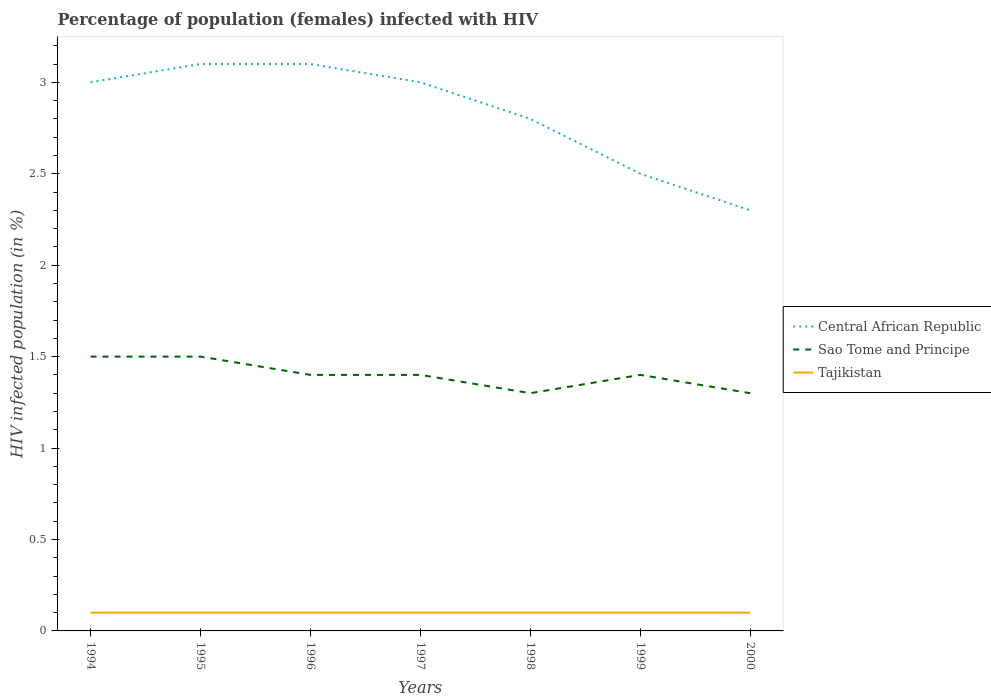How many different coloured lines are there?
Make the answer very short. 3. What is the total percentage of HIV infected female population in Tajikistan in the graph?
Your answer should be compact. 0. What is the difference between the highest and the second highest percentage of HIV infected female population in Tajikistan?
Offer a very short reply. 0. What is the difference between the highest and the lowest percentage of HIV infected female population in Tajikistan?
Provide a short and direct response. 7. Is the percentage of HIV infected female population in Sao Tome and Principe strictly greater than the percentage of HIV infected female population in Central African Republic over the years?
Keep it short and to the point. Yes. What is the difference between two consecutive major ticks on the Y-axis?
Make the answer very short. 0.5. Does the graph contain any zero values?
Offer a terse response. No. How are the legend labels stacked?
Make the answer very short. Vertical. What is the title of the graph?
Give a very brief answer. Percentage of population (females) infected with HIV. What is the label or title of the X-axis?
Your answer should be compact. Years. What is the label or title of the Y-axis?
Your answer should be compact. HIV infected population (in %). What is the HIV infected population (in %) of Central African Republic in 1994?
Offer a very short reply. 3. What is the HIV infected population (in %) of Tajikistan in 1994?
Offer a terse response. 0.1. What is the HIV infected population (in %) in Sao Tome and Principe in 1995?
Your answer should be very brief. 1.5. What is the HIV infected population (in %) of Tajikistan in 1995?
Ensure brevity in your answer.  0.1. What is the HIV infected population (in %) of Tajikistan in 1996?
Your answer should be very brief. 0.1. What is the HIV infected population (in %) of Central African Republic in 1997?
Your answer should be compact. 3. What is the HIV infected population (in %) of Central African Republic in 1999?
Make the answer very short. 2.5. What is the HIV infected population (in %) of Sao Tome and Principe in 1999?
Provide a short and direct response. 1.4. What is the HIV infected population (in %) in Tajikistan in 1999?
Make the answer very short. 0.1. What is the HIV infected population (in %) in Sao Tome and Principe in 2000?
Your answer should be compact. 1.3. What is the HIV infected population (in %) of Tajikistan in 2000?
Offer a very short reply. 0.1. Across all years, what is the maximum HIV infected population (in %) in Sao Tome and Principe?
Offer a very short reply. 1.5. Across all years, what is the maximum HIV infected population (in %) in Tajikistan?
Provide a succinct answer. 0.1. What is the total HIV infected population (in %) in Central African Republic in the graph?
Your response must be concise. 19.8. What is the total HIV infected population (in %) of Sao Tome and Principe in the graph?
Your response must be concise. 9.8. What is the total HIV infected population (in %) of Tajikistan in the graph?
Your answer should be very brief. 0.7. What is the difference between the HIV infected population (in %) in Sao Tome and Principe in 1994 and that in 1995?
Provide a short and direct response. 0. What is the difference between the HIV infected population (in %) of Central African Republic in 1994 and that in 1996?
Offer a terse response. -0.1. What is the difference between the HIV infected population (in %) in Sao Tome and Principe in 1994 and that in 1996?
Keep it short and to the point. 0.1. What is the difference between the HIV infected population (in %) of Tajikistan in 1994 and that in 1996?
Keep it short and to the point. 0. What is the difference between the HIV infected population (in %) of Sao Tome and Principe in 1994 and that in 1999?
Keep it short and to the point. 0.1. What is the difference between the HIV infected population (in %) in Tajikistan in 1994 and that in 2000?
Your answer should be very brief. 0. What is the difference between the HIV infected population (in %) in Tajikistan in 1995 and that in 1996?
Keep it short and to the point. 0. What is the difference between the HIV infected population (in %) in Central African Republic in 1995 and that in 1998?
Provide a succinct answer. 0.3. What is the difference between the HIV infected population (in %) of Sao Tome and Principe in 1995 and that in 1998?
Your response must be concise. 0.2. What is the difference between the HIV infected population (in %) of Tajikistan in 1995 and that in 1998?
Ensure brevity in your answer.  0. What is the difference between the HIV infected population (in %) of Central African Republic in 1995 and that in 2000?
Your answer should be very brief. 0.8. What is the difference between the HIV infected population (in %) in Sao Tome and Principe in 1996 and that in 1997?
Provide a short and direct response. 0. What is the difference between the HIV infected population (in %) of Sao Tome and Principe in 1996 and that in 1999?
Keep it short and to the point. 0. What is the difference between the HIV infected population (in %) of Tajikistan in 1996 and that in 1999?
Your answer should be very brief. 0. What is the difference between the HIV infected population (in %) of Tajikistan in 1996 and that in 2000?
Ensure brevity in your answer.  0. What is the difference between the HIV infected population (in %) in Central African Republic in 1997 and that in 1998?
Provide a short and direct response. 0.2. What is the difference between the HIV infected population (in %) in Tajikistan in 1997 and that in 1999?
Provide a short and direct response. 0. What is the difference between the HIV infected population (in %) of Central African Republic in 1997 and that in 2000?
Ensure brevity in your answer.  0.7. What is the difference between the HIV infected population (in %) in Sao Tome and Principe in 1997 and that in 2000?
Ensure brevity in your answer.  0.1. What is the difference between the HIV infected population (in %) of Sao Tome and Principe in 1998 and that in 1999?
Offer a terse response. -0.1. What is the difference between the HIV infected population (in %) of Tajikistan in 1998 and that in 1999?
Offer a terse response. 0. What is the difference between the HIV infected population (in %) in Sao Tome and Principe in 1999 and that in 2000?
Provide a succinct answer. 0.1. What is the difference between the HIV infected population (in %) in Central African Republic in 1994 and the HIV infected population (in %) in Sao Tome and Principe in 1995?
Offer a very short reply. 1.5. What is the difference between the HIV infected population (in %) in Central African Republic in 1994 and the HIV infected population (in %) in Tajikistan in 1995?
Ensure brevity in your answer.  2.9. What is the difference between the HIV infected population (in %) in Sao Tome and Principe in 1994 and the HIV infected population (in %) in Tajikistan in 1996?
Provide a short and direct response. 1.4. What is the difference between the HIV infected population (in %) in Sao Tome and Principe in 1994 and the HIV infected population (in %) in Tajikistan in 1997?
Provide a short and direct response. 1.4. What is the difference between the HIV infected population (in %) of Central African Republic in 1994 and the HIV infected population (in %) of Sao Tome and Principe in 1998?
Provide a short and direct response. 1.7. What is the difference between the HIV infected population (in %) in Central African Republic in 1994 and the HIV infected population (in %) in Tajikistan in 1998?
Give a very brief answer. 2.9. What is the difference between the HIV infected population (in %) of Sao Tome and Principe in 1994 and the HIV infected population (in %) of Tajikistan in 1998?
Offer a very short reply. 1.4. What is the difference between the HIV infected population (in %) of Central African Republic in 1994 and the HIV infected population (in %) of Sao Tome and Principe in 1999?
Provide a succinct answer. 1.6. What is the difference between the HIV infected population (in %) of Central African Republic in 1994 and the HIV infected population (in %) of Tajikistan in 1999?
Make the answer very short. 2.9. What is the difference between the HIV infected population (in %) in Sao Tome and Principe in 1994 and the HIV infected population (in %) in Tajikistan in 1999?
Your answer should be compact. 1.4. What is the difference between the HIV infected population (in %) in Sao Tome and Principe in 1995 and the HIV infected population (in %) in Tajikistan in 1996?
Offer a terse response. 1.4. What is the difference between the HIV infected population (in %) in Central African Republic in 1995 and the HIV infected population (in %) in Tajikistan in 1997?
Ensure brevity in your answer.  3. What is the difference between the HIV infected population (in %) in Central African Republic in 1995 and the HIV infected population (in %) in Sao Tome and Principe in 1998?
Offer a very short reply. 1.8. What is the difference between the HIV infected population (in %) in Central African Republic in 1995 and the HIV infected population (in %) in Sao Tome and Principe in 1999?
Provide a succinct answer. 1.7. What is the difference between the HIV infected population (in %) in Central African Republic in 1995 and the HIV infected population (in %) in Tajikistan in 1999?
Your response must be concise. 3. What is the difference between the HIV infected population (in %) of Sao Tome and Principe in 1995 and the HIV infected population (in %) of Tajikistan in 1999?
Give a very brief answer. 1.4. What is the difference between the HIV infected population (in %) of Central African Republic in 1995 and the HIV infected population (in %) of Sao Tome and Principe in 2000?
Your answer should be compact. 1.8. What is the difference between the HIV infected population (in %) in Sao Tome and Principe in 1995 and the HIV infected population (in %) in Tajikistan in 2000?
Your answer should be very brief. 1.4. What is the difference between the HIV infected population (in %) of Central African Republic in 1996 and the HIV infected population (in %) of Sao Tome and Principe in 1997?
Ensure brevity in your answer.  1.7. What is the difference between the HIV infected population (in %) in Central African Republic in 1996 and the HIV infected population (in %) in Tajikistan in 1997?
Offer a terse response. 3. What is the difference between the HIV infected population (in %) in Sao Tome and Principe in 1996 and the HIV infected population (in %) in Tajikistan in 1997?
Provide a short and direct response. 1.3. What is the difference between the HIV infected population (in %) in Central African Republic in 1996 and the HIV infected population (in %) in Tajikistan in 1998?
Offer a very short reply. 3. What is the difference between the HIV infected population (in %) of Sao Tome and Principe in 1996 and the HIV infected population (in %) of Tajikistan in 1998?
Ensure brevity in your answer.  1.3. What is the difference between the HIV infected population (in %) in Central African Republic in 1996 and the HIV infected population (in %) in Sao Tome and Principe in 1999?
Provide a short and direct response. 1.7. What is the difference between the HIV infected population (in %) in Central African Republic in 1996 and the HIV infected population (in %) in Tajikistan in 1999?
Provide a succinct answer. 3. What is the difference between the HIV infected population (in %) of Central African Republic in 1996 and the HIV infected population (in %) of Sao Tome and Principe in 2000?
Keep it short and to the point. 1.8. What is the difference between the HIV infected population (in %) of Central African Republic in 1997 and the HIV infected population (in %) of Sao Tome and Principe in 1998?
Your answer should be very brief. 1.7. What is the difference between the HIV infected population (in %) in Sao Tome and Principe in 1997 and the HIV infected population (in %) in Tajikistan in 1999?
Offer a very short reply. 1.3. What is the difference between the HIV infected population (in %) in Central African Republic in 1997 and the HIV infected population (in %) in Sao Tome and Principe in 2000?
Make the answer very short. 1.7. What is the difference between the HIV infected population (in %) of Central African Republic in 1998 and the HIV infected population (in %) of Tajikistan in 1999?
Offer a terse response. 2.7. What is the difference between the HIV infected population (in %) of Sao Tome and Principe in 1998 and the HIV infected population (in %) of Tajikistan in 1999?
Ensure brevity in your answer.  1.2. What is the difference between the HIV infected population (in %) in Central African Republic in 1998 and the HIV infected population (in %) in Sao Tome and Principe in 2000?
Offer a terse response. 1.5. What is the difference between the HIV infected population (in %) of Sao Tome and Principe in 1998 and the HIV infected population (in %) of Tajikistan in 2000?
Ensure brevity in your answer.  1.2. What is the difference between the HIV infected population (in %) of Central African Republic in 1999 and the HIV infected population (in %) of Tajikistan in 2000?
Offer a terse response. 2.4. What is the difference between the HIV infected population (in %) of Sao Tome and Principe in 1999 and the HIV infected population (in %) of Tajikistan in 2000?
Give a very brief answer. 1.3. What is the average HIV infected population (in %) in Central African Republic per year?
Offer a terse response. 2.83. What is the average HIV infected population (in %) in Sao Tome and Principe per year?
Make the answer very short. 1.4. In the year 1994, what is the difference between the HIV infected population (in %) in Central African Republic and HIV infected population (in %) in Sao Tome and Principe?
Keep it short and to the point. 1.5. In the year 1994, what is the difference between the HIV infected population (in %) of Central African Republic and HIV infected population (in %) of Tajikistan?
Offer a very short reply. 2.9. In the year 1994, what is the difference between the HIV infected population (in %) of Sao Tome and Principe and HIV infected population (in %) of Tajikistan?
Your answer should be very brief. 1.4. In the year 1995, what is the difference between the HIV infected population (in %) in Central African Republic and HIV infected population (in %) in Tajikistan?
Keep it short and to the point. 3. In the year 1996, what is the difference between the HIV infected population (in %) of Central African Republic and HIV infected population (in %) of Sao Tome and Principe?
Your response must be concise. 1.7. In the year 1996, what is the difference between the HIV infected population (in %) of Sao Tome and Principe and HIV infected population (in %) of Tajikistan?
Offer a very short reply. 1.3. In the year 1997, what is the difference between the HIV infected population (in %) of Central African Republic and HIV infected population (in %) of Sao Tome and Principe?
Offer a terse response. 1.6. In the year 1997, what is the difference between the HIV infected population (in %) of Central African Republic and HIV infected population (in %) of Tajikistan?
Your answer should be very brief. 2.9. In the year 1998, what is the difference between the HIV infected population (in %) of Central African Republic and HIV infected population (in %) of Sao Tome and Principe?
Keep it short and to the point. 1.5. In the year 1998, what is the difference between the HIV infected population (in %) in Central African Republic and HIV infected population (in %) in Tajikistan?
Make the answer very short. 2.7. In the year 1998, what is the difference between the HIV infected population (in %) in Sao Tome and Principe and HIV infected population (in %) in Tajikistan?
Keep it short and to the point. 1.2. In the year 2000, what is the difference between the HIV infected population (in %) of Central African Republic and HIV infected population (in %) of Sao Tome and Principe?
Ensure brevity in your answer.  1. In the year 2000, what is the difference between the HIV infected population (in %) of Sao Tome and Principe and HIV infected population (in %) of Tajikistan?
Offer a terse response. 1.2. What is the ratio of the HIV infected population (in %) in Sao Tome and Principe in 1994 to that in 1995?
Your response must be concise. 1. What is the ratio of the HIV infected population (in %) of Tajikistan in 1994 to that in 1995?
Provide a short and direct response. 1. What is the ratio of the HIV infected population (in %) of Sao Tome and Principe in 1994 to that in 1996?
Your answer should be very brief. 1.07. What is the ratio of the HIV infected population (in %) of Sao Tome and Principe in 1994 to that in 1997?
Offer a very short reply. 1.07. What is the ratio of the HIV infected population (in %) in Central African Republic in 1994 to that in 1998?
Your response must be concise. 1.07. What is the ratio of the HIV infected population (in %) of Sao Tome and Principe in 1994 to that in 1998?
Make the answer very short. 1.15. What is the ratio of the HIV infected population (in %) in Tajikistan in 1994 to that in 1998?
Offer a terse response. 1. What is the ratio of the HIV infected population (in %) in Central African Republic in 1994 to that in 1999?
Make the answer very short. 1.2. What is the ratio of the HIV infected population (in %) in Sao Tome and Principe in 1994 to that in 1999?
Make the answer very short. 1.07. What is the ratio of the HIV infected population (in %) of Tajikistan in 1994 to that in 1999?
Ensure brevity in your answer.  1. What is the ratio of the HIV infected population (in %) of Central African Republic in 1994 to that in 2000?
Your response must be concise. 1.3. What is the ratio of the HIV infected population (in %) of Sao Tome and Principe in 1994 to that in 2000?
Offer a very short reply. 1.15. What is the ratio of the HIV infected population (in %) of Sao Tome and Principe in 1995 to that in 1996?
Your answer should be very brief. 1.07. What is the ratio of the HIV infected population (in %) in Tajikistan in 1995 to that in 1996?
Make the answer very short. 1. What is the ratio of the HIV infected population (in %) of Central African Republic in 1995 to that in 1997?
Provide a short and direct response. 1.03. What is the ratio of the HIV infected population (in %) of Sao Tome and Principe in 1995 to that in 1997?
Provide a succinct answer. 1.07. What is the ratio of the HIV infected population (in %) of Tajikistan in 1995 to that in 1997?
Make the answer very short. 1. What is the ratio of the HIV infected population (in %) of Central African Republic in 1995 to that in 1998?
Your answer should be compact. 1.11. What is the ratio of the HIV infected population (in %) of Sao Tome and Principe in 1995 to that in 1998?
Your answer should be very brief. 1.15. What is the ratio of the HIV infected population (in %) in Central African Republic in 1995 to that in 1999?
Offer a very short reply. 1.24. What is the ratio of the HIV infected population (in %) in Sao Tome and Principe in 1995 to that in 1999?
Offer a very short reply. 1.07. What is the ratio of the HIV infected population (in %) in Tajikistan in 1995 to that in 1999?
Provide a succinct answer. 1. What is the ratio of the HIV infected population (in %) of Central African Republic in 1995 to that in 2000?
Offer a terse response. 1.35. What is the ratio of the HIV infected population (in %) of Sao Tome and Principe in 1995 to that in 2000?
Ensure brevity in your answer.  1.15. What is the ratio of the HIV infected population (in %) in Tajikistan in 1996 to that in 1997?
Give a very brief answer. 1. What is the ratio of the HIV infected population (in %) in Central African Republic in 1996 to that in 1998?
Provide a succinct answer. 1.11. What is the ratio of the HIV infected population (in %) in Tajikistan in 1996 to that in 1998?
Your answer should be very brief. 1. What is the ratio of the HIV infected population (in %) of Central African Republic in 1996 to that in 1999?
Offer a terse response. 1.24. What is the ratio of the HIV infected population (in %) of Sao Tome and Principe in 1996 to that in 1999?
Make the answer very short. 1. What is the ratio of the HIV infected population (in %) of Central African Republic in 1996 to that in 2000?
Give a very brief answer. 1.35. What is the ratio of the HIV infected population (in %) of Central African Republic in 1997 to that in 1998?
Your answer should be very brief. 1.07. What is the ratio of the HIV infected population (in %) of Sao Tome and Principe in 1997 to that in 1998?
Your answer should be very brief. 1.08. What is the ratio of the HIV infected population (in %) in Central African Republic in 1997 to that in 1999?
Offer a very short reply. 1.2. What is the ratio of the HIV infected population (in %) in Tajikistan in 1997 to that in 1999?
Your response must be concise. 1. What is the ratio of the HIV infected population (in %) of Central African Republic in 1997 to that in 2000?
Keep it short and to the point. 1.3. What is the ratio of the HIV infected population (in %) in Sao Tome and Principe in 1997 to that in 2000?
Ensure brevity in your answer.  1.08. What is the ratio of the HIV infected population (in %) in Tajikistan in 1997 to that in 2000?
Offer a terse response. 1. What is the ratio of the HIV infected population (in %) in Central African Republic in 1998 to that in 1999?
Offer a very short reply. 1.12. What is the ratio of the HIV infected population (in %) in Sao Tome and Principe in 1998 to that in 1999?
Make the answer very short. 0.93. What is the ratio of the HIV infected population (in %) of Central African Republic in 1998 to that in 2000?
Provide a succinct answer. 1.22. What is the ratio of the HIV infected population (in %) of Sao Tome and Principe in 1998 to that in 2000?
Offer a terse response. 1. What is the ratio of the HIV infected population (in %) in Central African Republic in 1999 to that in 2000?
Give a very brief answer. 1.09. What is the ratio of the HIV infected population (in %) in Tajikistan in 1999 to that in 2000?
Provide a succinct answer. 1. What is the difference between the highest and the second highest HIV infected population (in %) in Central African Republic?
Provide a short and direct response. 0. What is the difference between the highest and the second highest HIV infected population (in %) of Sao Tome and Principe?
Your answer should be very brief. 0. What is the difference between the highest and the lowest HIV infected population (in %) in Central African Republic?
Provide a short and direct response. 0.8. What is the difference between the highest and the lowest HIV infected population (in %) in Sao Tome and Principe?
Make the answer very short. 0.2. 